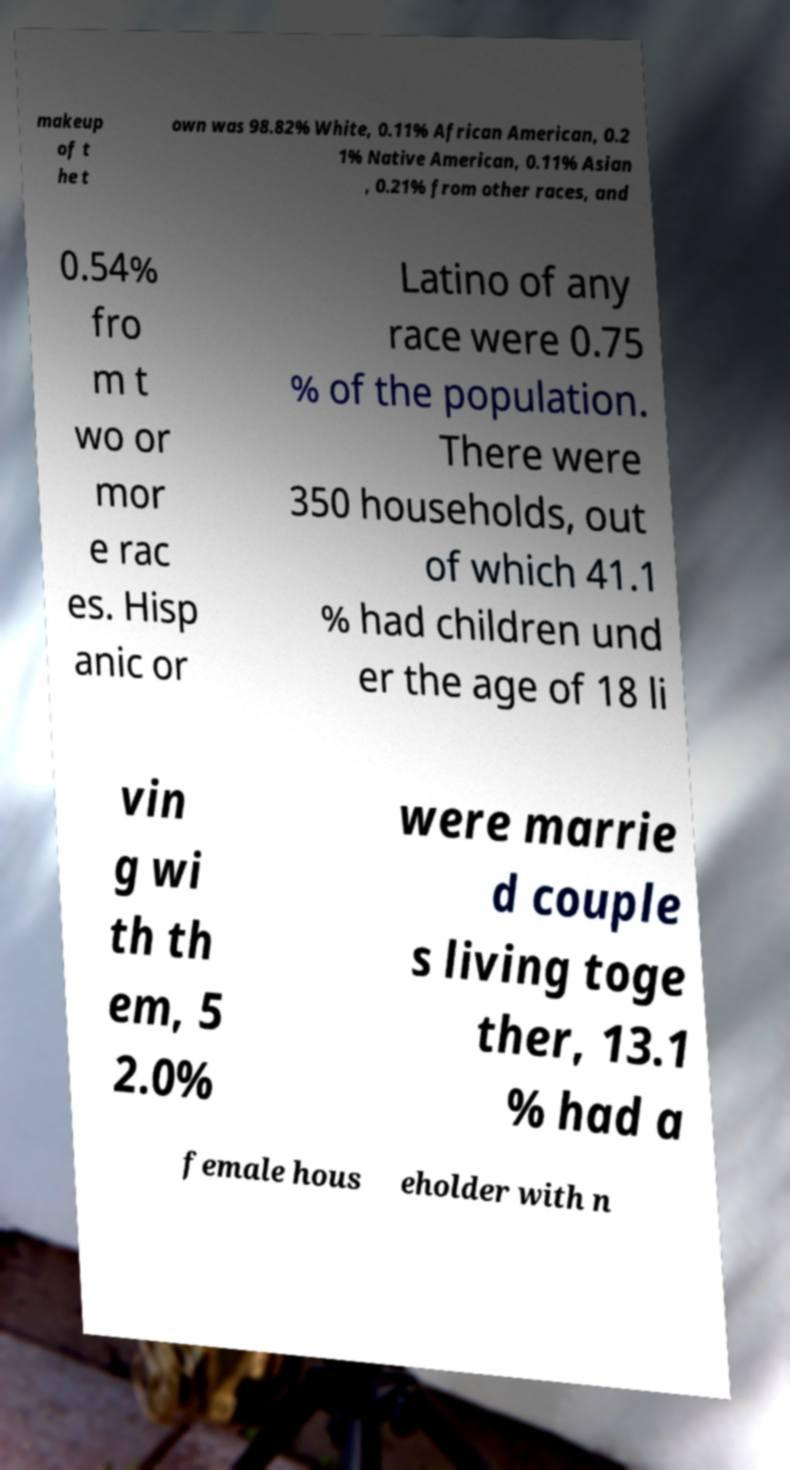What messages or text are displayed in this image? I need them in a readable, typed format. makeup of t he t own was 98.82% White, 0.11% African American, 0.2 1% Native American, 0.11% Asian , 0.21% from other races, and 0.54% fro m t wo or mor e rac es. Hisp anic or Latino of any race were 0.75 % of the population. There were 350 households, out of which 41.1 % had children und er the age of 18 li vin g wi th th em, 5 2.0% were marrie d couple s living toge ther, 13.1 % had a female hous eholder with n 